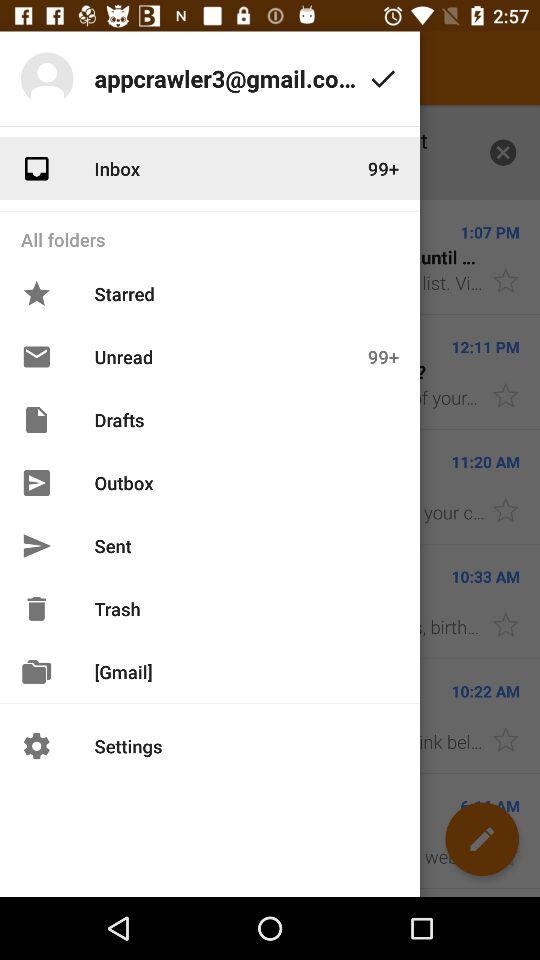How many unread messages are there? There are more than 99 unread messages. 